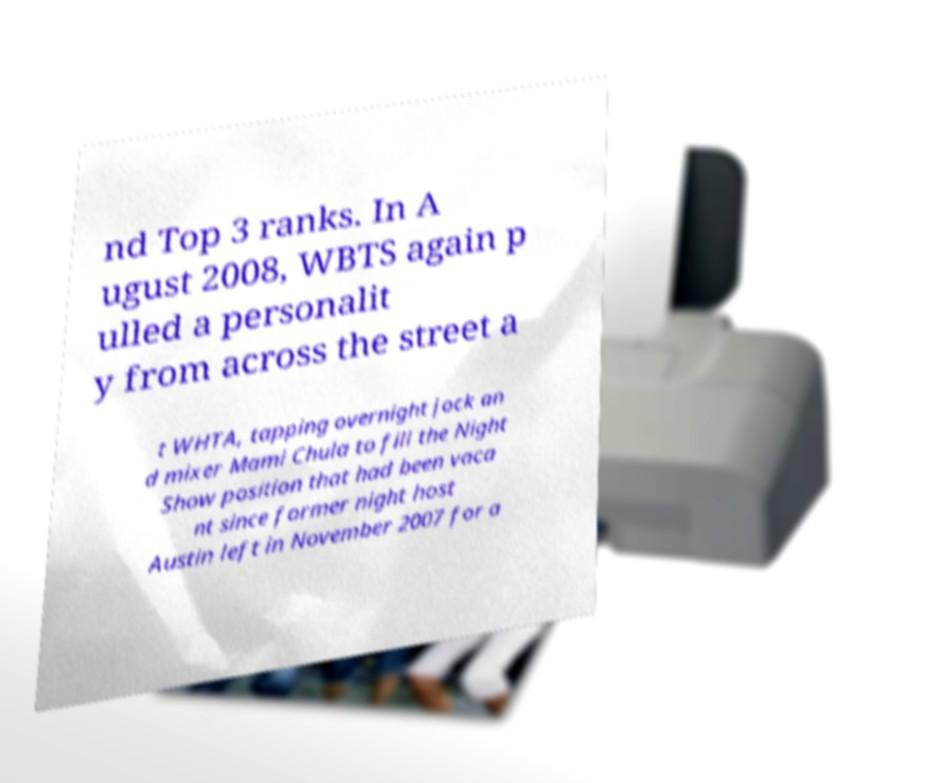I need the written content from this picture converted into text. Can you do that? nd Top 3 ranks. In A ugust 2008, WBTS again p ulled a personalit y from across the street a t WHTA, tapping overnight jock an d mixer Mami Chula to fill the Night Show position that had been vaca nt since former night host Austin left in November 2007 for a 